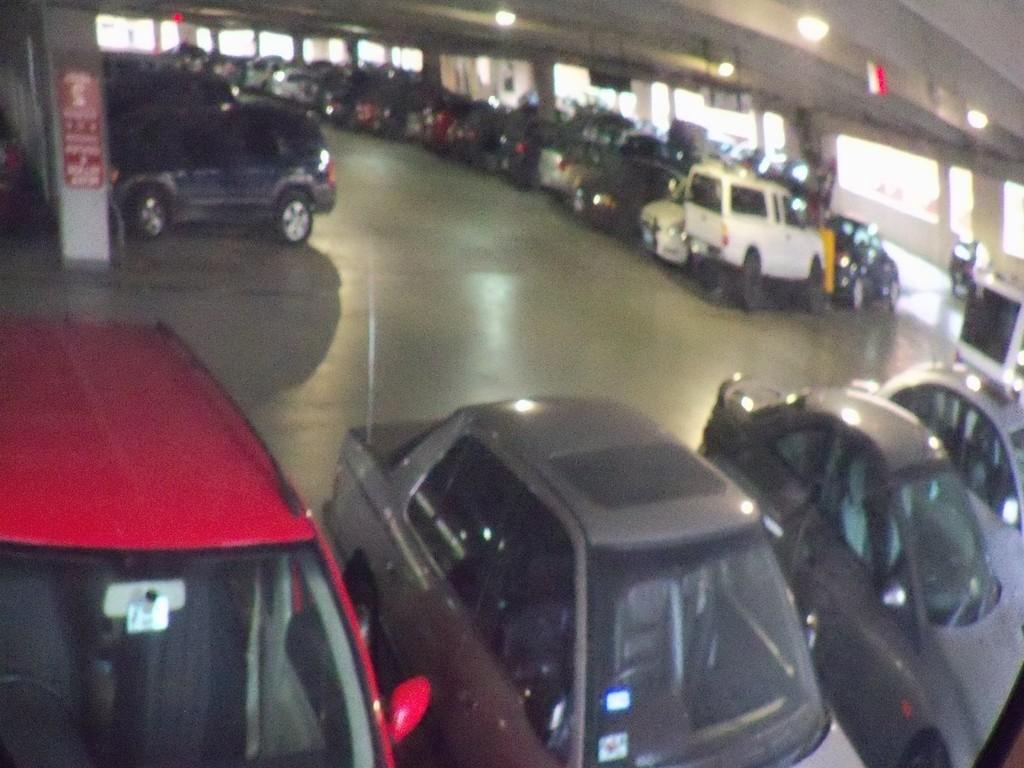Where was the image taken? The image is taken in a cellar. What can be seen in the parking area? There are cars placed in the parking area. What is placed on a pillar in the image? There is a board placed on a pillar. What is providing illumination in the image? Lights are visible at the top of the image. Can you see a playground in the image? There is no playground present in the image. What type of trail can be seen in the image? There is no trail visible in the image. 